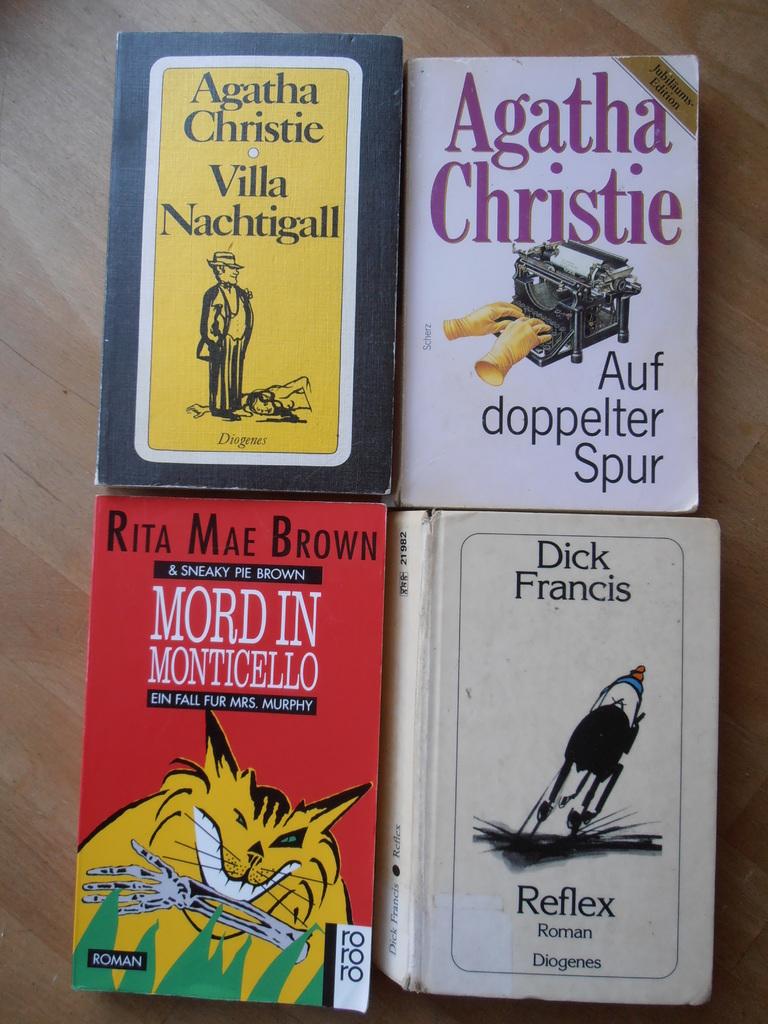What is the title of the red book?
Your response must be concise. Mord in monticello. 